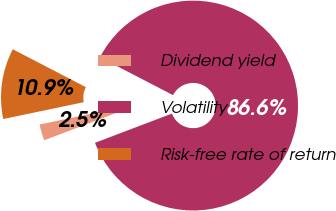Convert chart. <chart><loc_0><loc_0><loc_500><loc_500><pie_chart><fcel>Dividend yield<fcel>Volatility<fcel>Risk-free rate of return<nl><fcel>2.49%<fcel>86.61%<fcel>10.9%<nl></chart> 